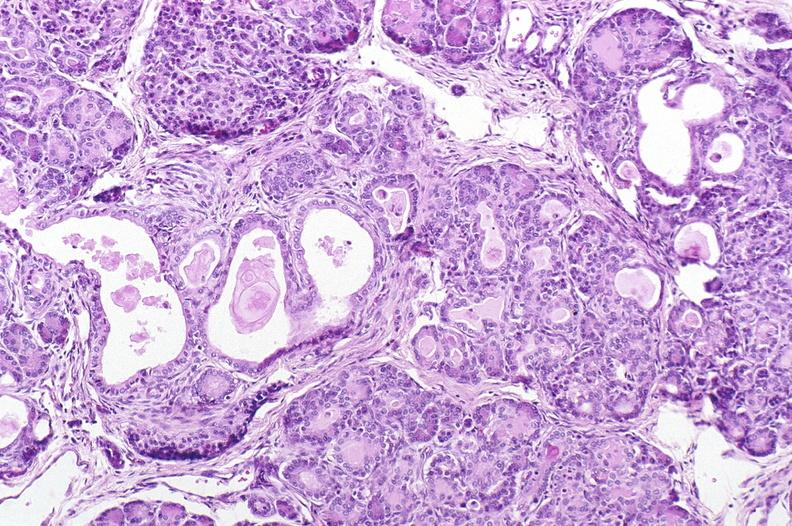does metastatic colon cancer show cystic fibrosis?
Answer the question using a single word or phrase. No 